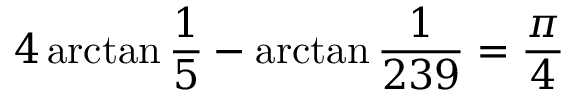Convert formula to latex. <formula><loc_0><loc_0><loc_500><loc_500>4 \arctan { \frac { 1 } { 5 } } - \arctan { \frac { 1 } { 2 3 9 } } = { \frac { \pi } { 4 } }</formula> 